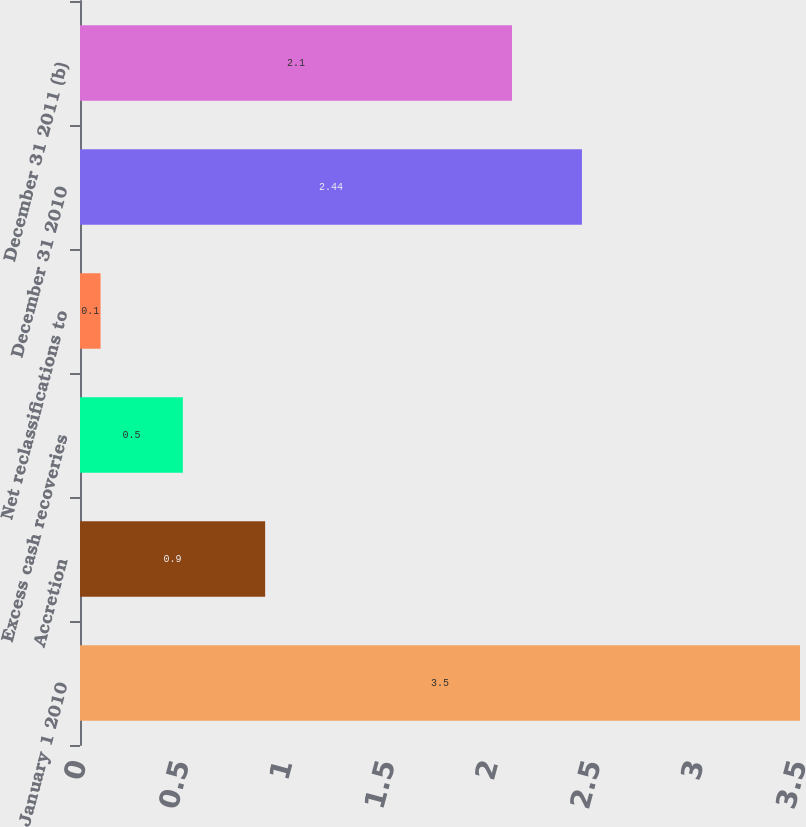<chart> <loc_0><loc_0><loc_500><loc_500><bar_chart><fcel>January 1 2010<fcel>Accretion<fcel>Excess cash recoveries<fcel>Net reclassifications to<fcel>December 31 2010<fcel>December 31 2011 (b)<nl><fcel>3.5<fcel>0.9<fcel>0.5<fcel>0.1<fcel>2.44<fcel>2.1<nl></chart> 